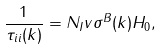<formula> <loc_0><loc_0><loc_500><loc_500>\frac { 1 } { \tau _ { i i } ( k ) } = N _ { I } v \sigma ^ { B } ( k ) H _ { 0 } ,</formula> 